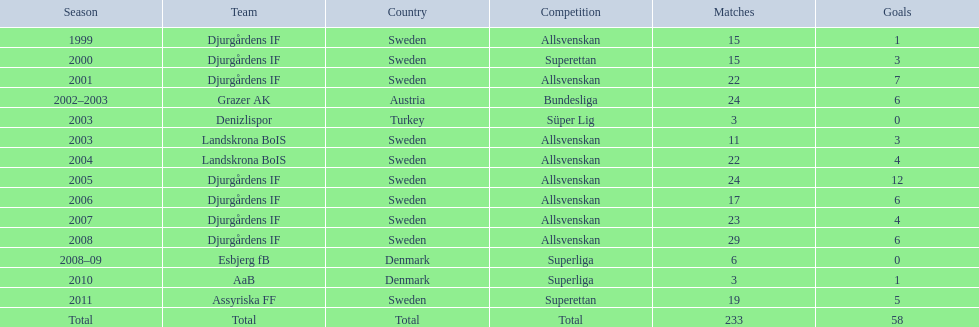Parse the full table. {'header': ['Season', 'Team', 'Country', 'Competition', 'Matches', 'Goals'], 'rows': [['1999', 'Djurgårdens IF', 'Sweden', 'Allsvenskan', '15', '1'], ['2000', 'Djurgårdens IF', 'Sweden', 'Superettan', '15', '3'], ['2001', 'Djurgårdens IF', 'Sweden', 'Allsvenskan', '22', '7'], ['2002–2003', 'Grazer AK', 'Austria', 'Bundesliga', '24', '6'], ['2003', 'Denizlispor', 'Turkey', 'Süper Lig', '3', '0'], ['2003', 'Landskrona BoIS', 'Sweden', 'Allsvenskan', '11', '3'], ['2004', 'Landskrona BoIS', 'Sweden', 'Allsvenskan', '22', '4'], ['2005', 'Djurgårdens IF', 'Sweden', 'Allsvenskan', '24', '12'], ['2006', 'Djurgårdens IF', 'Sweden', 'Allsvenskan', '17', '6'], ['2007', 'Djurgårdens IF', 'Sweden', 'Allsvenskan', '23', '4'], ['2008', 'Djurgårdens IF', 'Sweden', 'Allsvenskan', '29', '6'], ['2008–09', 'Esbjerg fB', 'Denmark', 'Superliga', '6', '0'], ['2010', 'AaB', 'Denmark', 'Superliga', '3', '1'], ['2011', 'Assyriska FF', 'Sweden', 'Superettan', '19', '5'], ['Total', 'Total', 'Total', 'Total', '233', '58']]} What season has the most goals? 2005. 